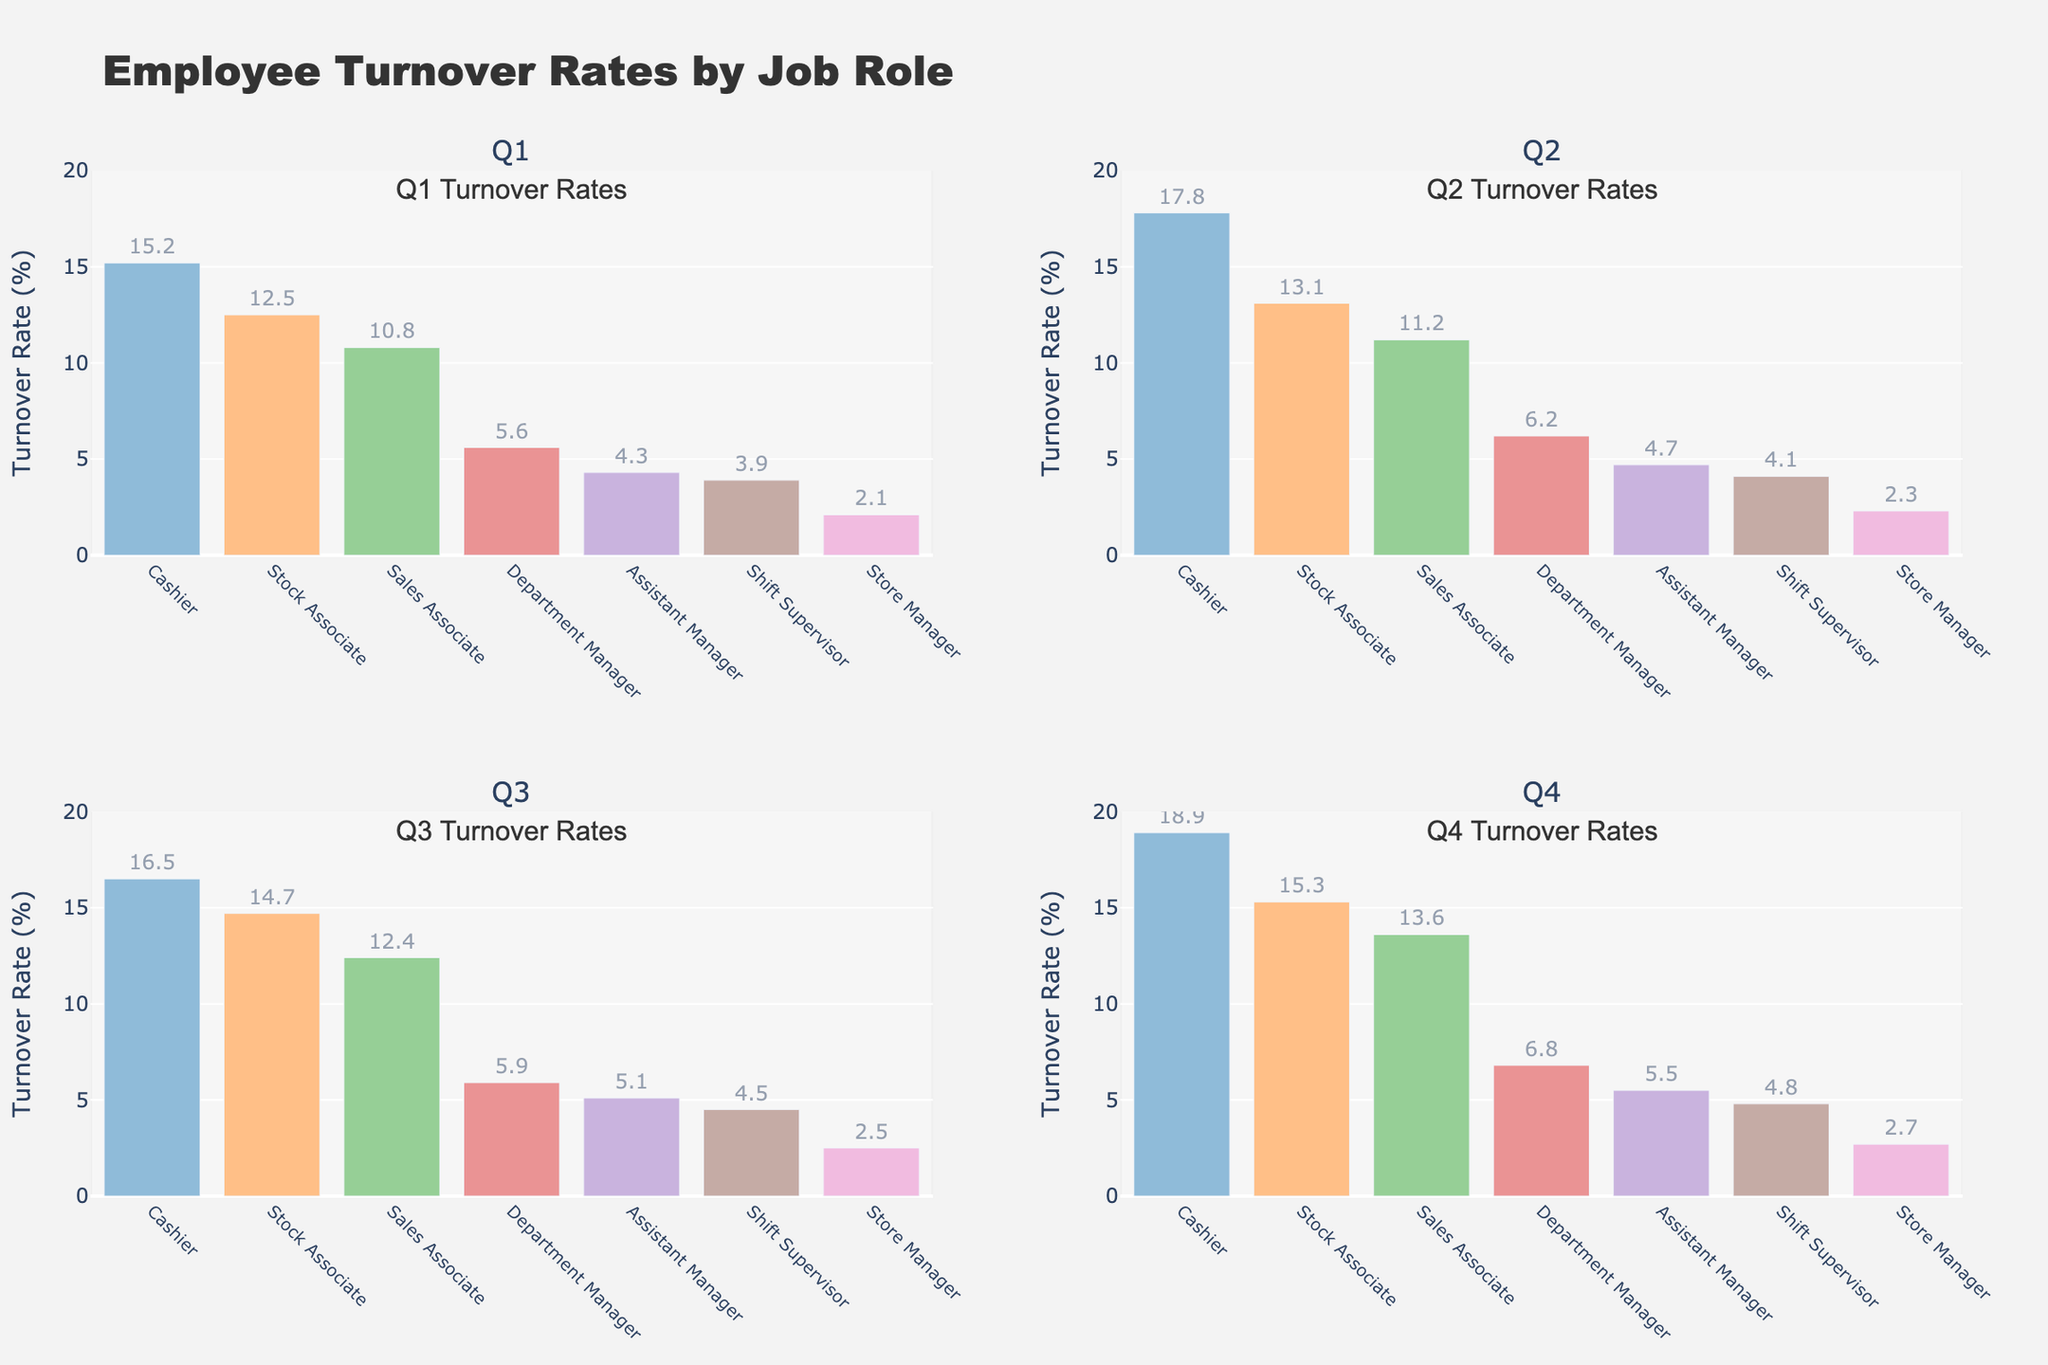Which platform has the highest user satisfaction on average? By observing the bar chart "User Satisfaction by Platform," we can see the heights of each bar. The platform with the tallest bar corresponds to the highest average user satisfaction.
Answer: GitHub Which action has the highest frequency? Examining the scatter plot "Effectiveness vs. Frequency," we can observe the x-axis values which represent frequency. The item farthest to the right has the highest frequency. From the hover data, this action is identified.
Answer: Comment Deletion (Reddit) How many actions have an effectiveness score above 90? From the scatter plot "Effectiveness vs. Frequency," examine the y-axis for points above the score of 90. Counting these points gives the number of actions.
Answer: 5 Which action is the least frequent among the top 5 most frequent actions? Referencing the pie chart "Top 5 Most Frequent Actions," each slice relates to an action's frequency. Looking at which slice represents the smallest percentage tells us the least frequent action in the top five.
Answer: Question Closure (Stack Overflow) Compare the average user satisfaction between Reddit and Discourse. Which is higher? From the bar chart "User Satisfaction by Platform," compare the height of the bars for Reddit and Discourse. The higher bar corresponds to higher average user satisfaction.
Answer: Reddit What is the most effective action for Wikipedia? By inspecting the box plot "Effectiveness Distribution" for Wikipedia and noting the highest data point, we determine the most effective action.
Answer: Page Protection Which platform has the widest range of effectiveness scores? In the box plot "Effectiveness Distribution," compare the length of the boxes and whiskers for each platform. The widest range is indicated by the longest box and whiskers.
Answer: Wikipedia 